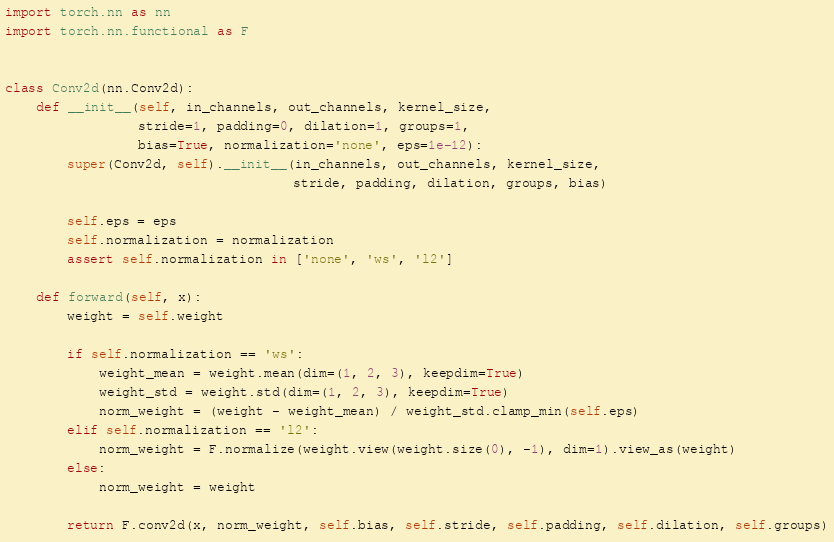<code> <loc_0><loc_0><loc_500><loc_500><_Python_>import torch.nn as nn
import torch.nn.functional as F


class Conv2d(nn.Conv2d):
    def __init__(self, in_channels, out_channels, kernel_size,
                 stride=1, padding=0, dilation=1, groups=1,
                 bias=True, normalization='none', eps=1e-12):
        super(Conv2d, self).__init__(in_channels, out_channels, kernel_size,
                                     stride, padding, dilation, groups, bias)

        self.eps = eps
        self.normalization = normalization
        assert self.normalization in ['none', 'ws', 'l2']

    def forward(self, x):
        weight = self.weight

        if self.normalization == 'ws':
            weight_mean = weight.mean(dim=(1, 2, 3), keepdim=True)
            weight_std = weight.std(dim=(1, 2, 3), keepdim=True)
            norm_weight = (weight - weight_mean) / weight_std.clamp_min(self.eps)
        elif self.normalization == 'l2':
            norm_weight = F.normalize(weight.view(weight.size(0), -1), dim=1).view_as(weight)
        else:
            norm_weight = weight

        return F.conv2d(x, norm_weight, self.bias, self.stride, self.padding, self.dilation, self.groups)
</code> 